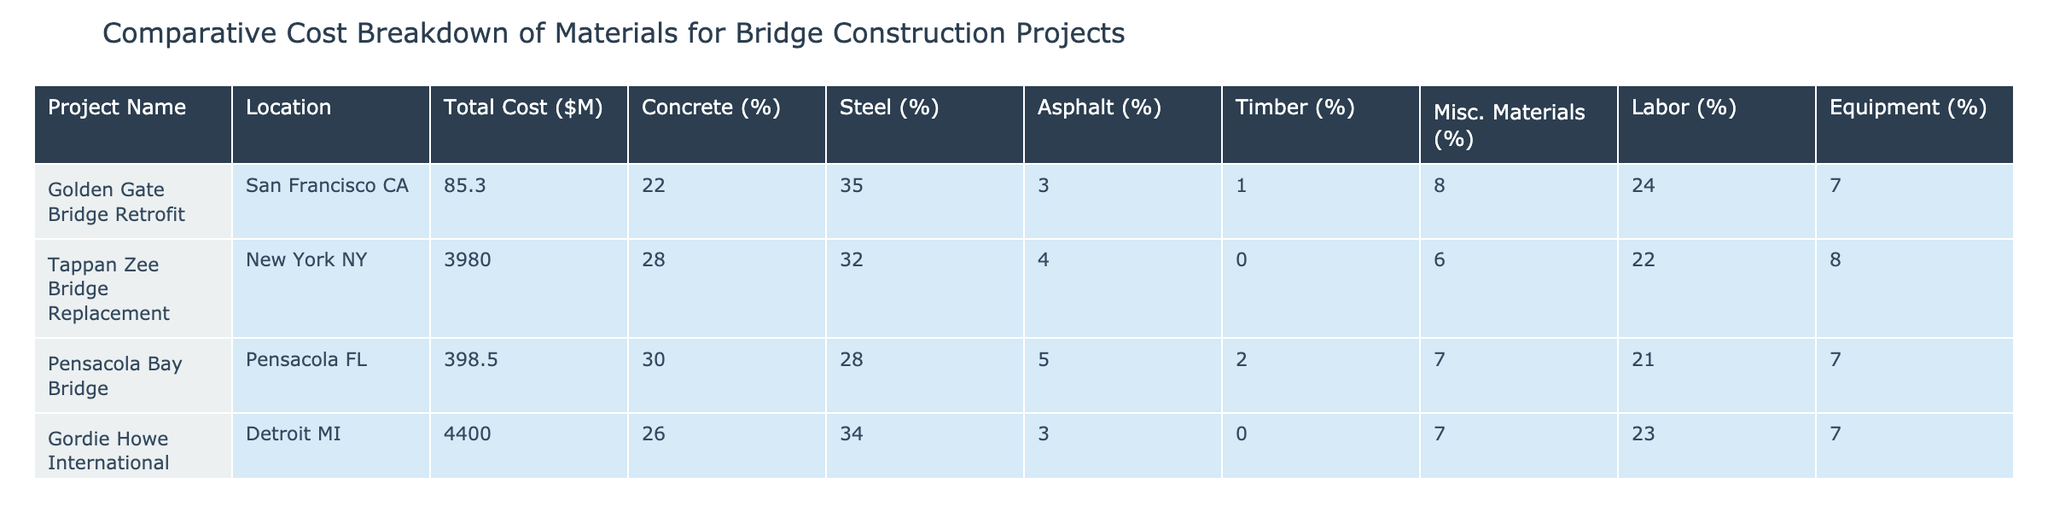What is the total cost of the Tappan Zee Bridge Replacement project? The table shows the total cost for the Tappan Zee Bridge Replacement project listed as 3980 million dollars.
Answer: 3980 million dollars Which project has the highest percentage of concrete used? By examining the table, the Pensacola Bay Bridge shows the highest percentage of concrete usage at 30%.
Answer: Pensacola Bay Bridge How much of the total cost does labor account for in the Gordie Howe International Bridge? The labor percentage for the Gordie Howe International Bridge is 7%, so the labor cost can be calculated as 7% of total cost 4400 million dollars, which equals 308 million dollars.
Answer: 308 million dollars Is the percentage of asphalt used in the I-74 Mississippi River Bridge greater than that in the Golden Gate Bridge Retrofit? The I-74 Mississippi River Bridge uses 4% asphalt, while the Golden Gate Bridge Retrofit uses only 3%, meaning that the I-74 Mississippi River Bridge has a greater percentage of asphalt usage.
Answer: Yes What is the total percentage of materials (concrete, steel, asphalt, timber, miscellaneous materials) used in the Pensacola Bay Bridge? Adding up the percentages for the Pensacola Bay Bridge: 30 (concrete) + 28 (steel) + 5 (asphalt) + 2 (timber) + 7 (miscellaneous) gives a total of 72%.
Answer: 72% Which project has the least budget allocated for labor, and what is the percentage? The projects listed show that the Tappan Zee Bridge Replacement has the lowest labor allocation at 6%.
Answer: Tappan Zee Bridge Replacement, 6% If we consider the total budget of all five projects, what is the average budget allocation for each project? Summing the total costs of all five projects: 85.3 + 3980 + 398.5 + 4400 + 1200 = 10064.8 million dollars. Dividing that by the number of projects (5) gives an average of 2012.96 million dollars.
Answer: 2012.96 million dollars Which project uses the highest percentage of steel? The table indicates that the Golden Gate Bridge Retrofit has the highest steel percentage at 35%.
Answer: Golden Gate Bridge Retrofit What is the difference in total cost between the Gordie Howe International Bridge and the Pensacola Bay Bridge? The total cost of the Gordie Howe International Bridge is 4400 million dollars, while the Pensacola Bay Bridge costs 398.5 million dollars. The difference is 4400 - 398.5 = 4001.5 million dollars.
Answer: 4001.5 million dollars Does any project use timber in its construction? Upon reviewing the table, the I-74 Mississippi River Bridge shows a timber usage of 1%, indicating that it does include timber in its construction.
Answer: Yes 